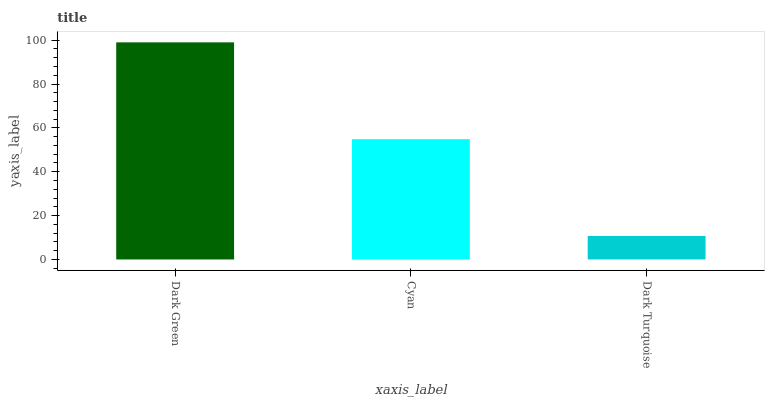Is Dark Turquoise the minimum?
Answer yes or no. Yes. Is Dark Green the maximum?
Answer yes or no. Yes. Is Cyan the minimum?
Answer yes or no. No. Is Cyan the maximum?
Answer yes or no. No. Is Dark Green greater than Cyan?
Answer yes or no. Yes. Is Cyan less than Dark Green?
Answer yes or no. Yes. Is Cyan greater than Dark Green?
Answer yes or no. No. Is Dark Green less than Cyan?
Answer yes or no. No. Is Cyan the high median?
Answer yes or no. Yes. Is Cyan the low median?
Answer yes or no. Yes. Is Dark Turquoise the high median?
Answer yes or no. No. Is Dark Turquoise the low median?
Answer yes or no. No. 